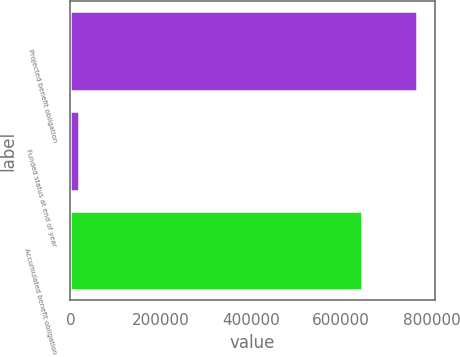Convert chart. <chart><loc_0><loc_0><loc_500><loc_500><bar_chart><fcel>Projected benefit obligation<fcel>Funded status at end of year<fcel>Accumulated benefit obligation<nl><fcel>768672<fcel>18078<fcel>645431<nl></chart> 